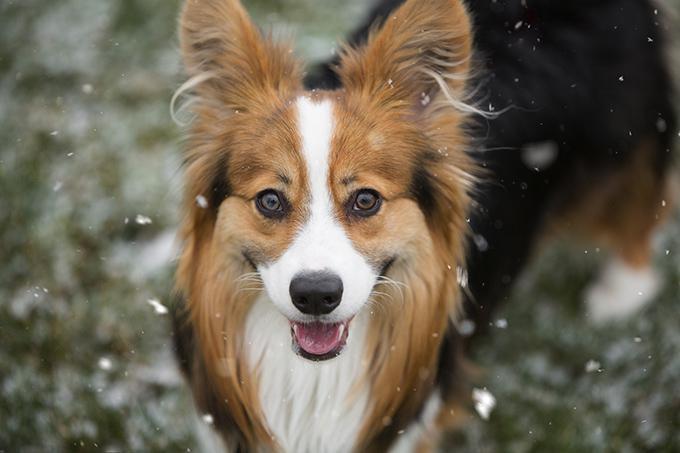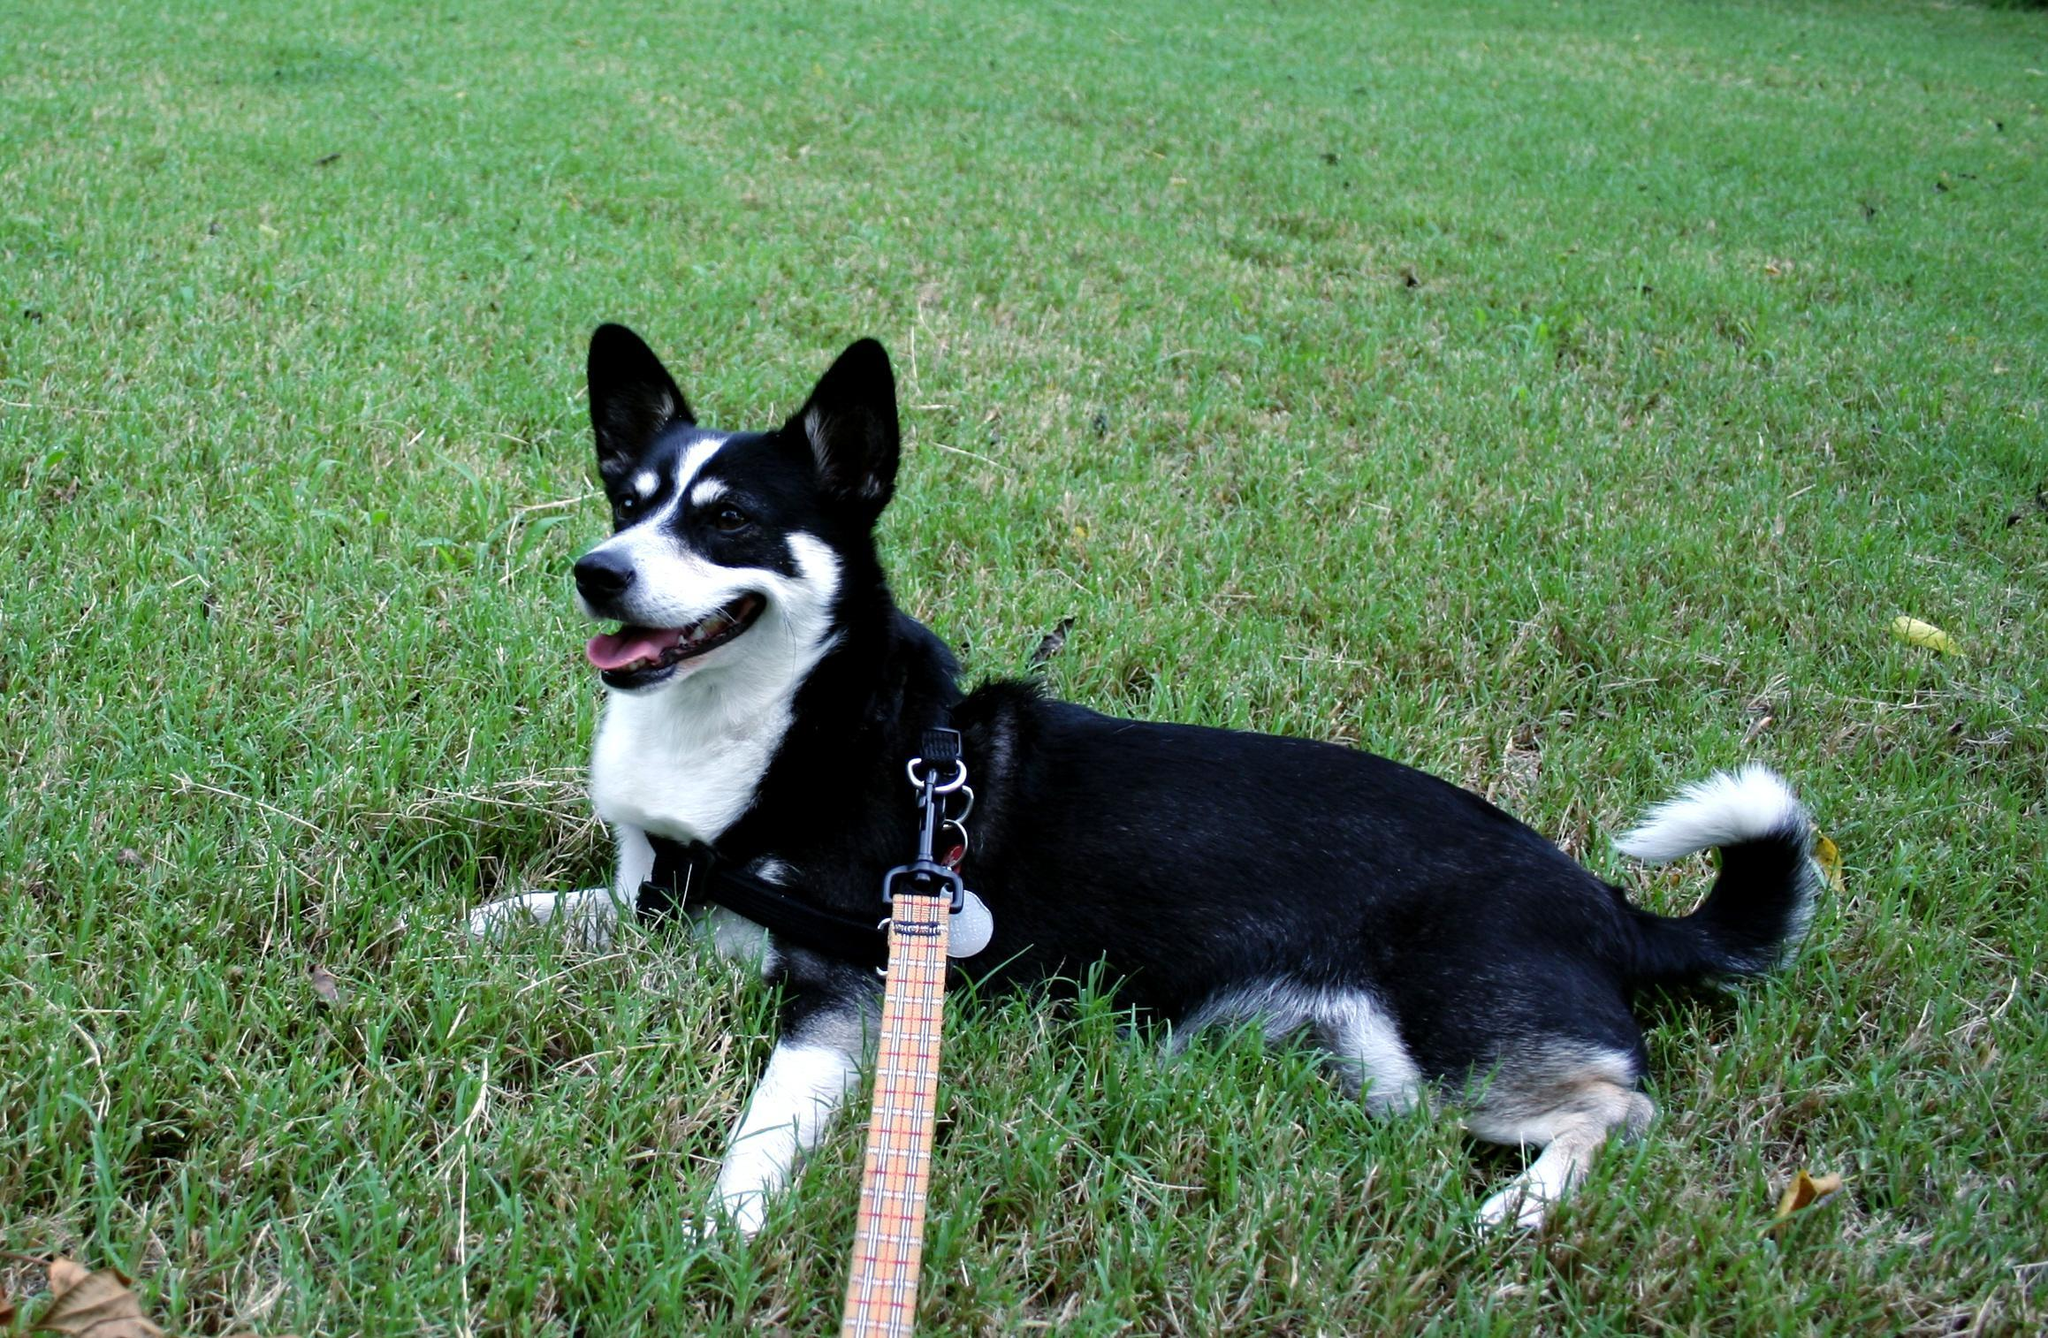The first image is the image on the left, the second image is the image on the right. Evaluate the accuracy of this statement regarding the images: "There are black and white corgis". Is it true? Answer yes or no. Yes. 